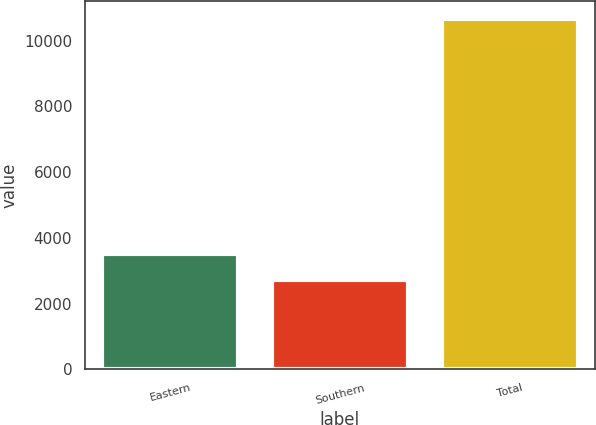Convert chart to OTSL. <chart><loc_0><loc_0><loc_500><loc_500><bar_chart><fcel>Eastern<fcel>Southern<fcel>Total<nl><fcel>3518.94<fcel>2724.7<fcel>10667.1<nl></chart> 